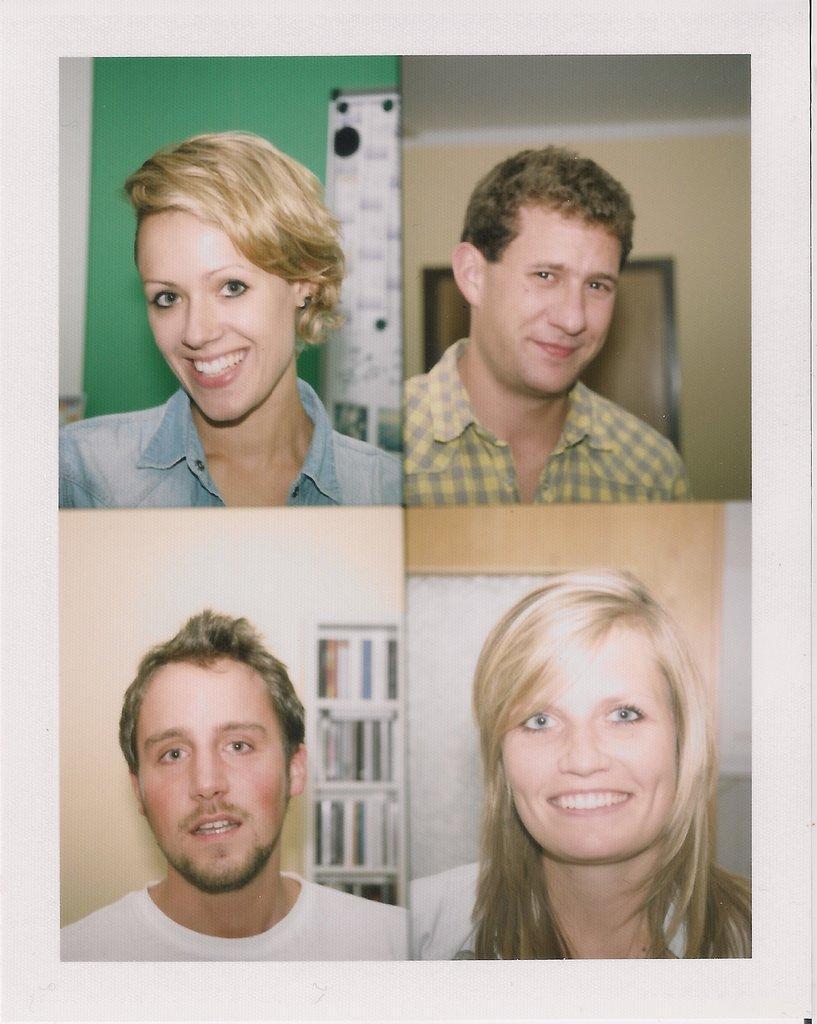In one or two sentences, can you explain what this image depicts? In this image I can see four people with different color dresses. I can see three people are smiling. And there is a wall behind these people. These walls are in cream and green color. 